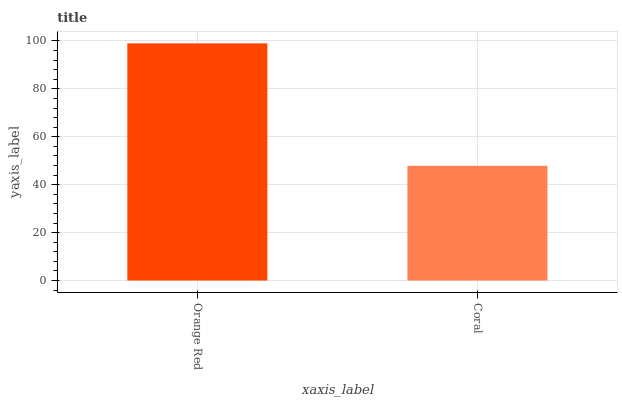Is Coral the minimum?
Answer yes or no. Yes. Is Orange Red the maximum?
Answer yes or no. Yes. Is Coral the maximum?
Answer yes or no. No. Is Orange Red greater than Coral?
Answer yes or no. Yes. Is Coral less than Orange Red?
Answer yes or no. Yes. Is Coral greater than Orange Red?
Answer yes or no. No. Is Orange Red less than Coral?
Answer yes or no. No. Is Orange Red the high median?
Answer yes or no. Yes. Is Coral the low median?
Answer yes or no. Yes. Is Coral the high median?
Answer yes or no. No. Is Orange Red the low median?
Answer yes or no. No. 